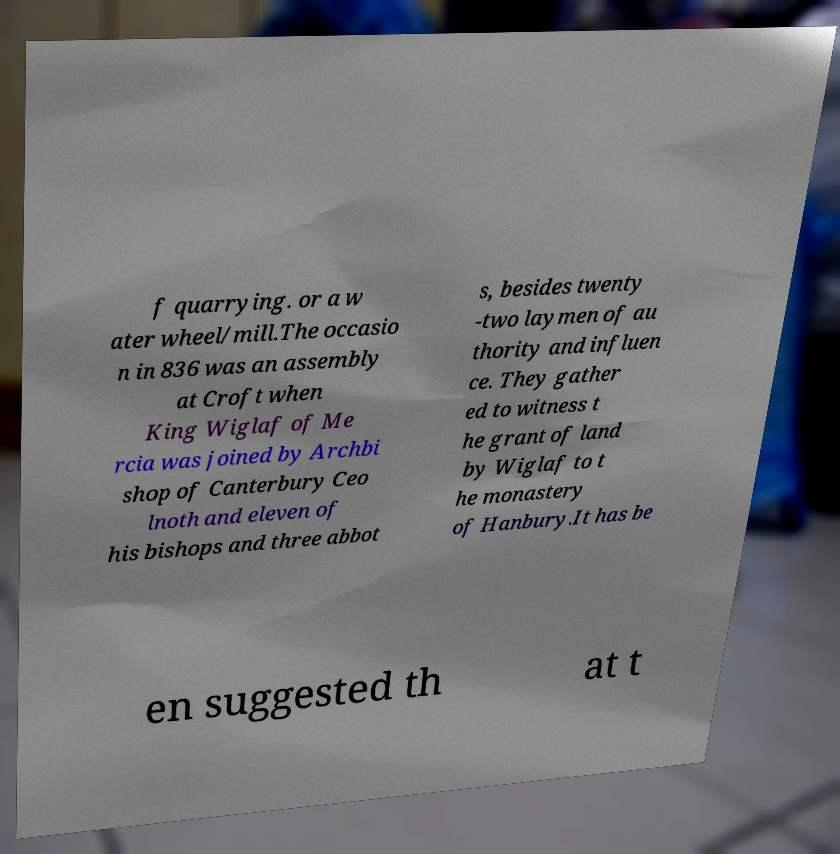Please identify and transcribe the text found in this image. f quarrying. or a w ater wheel/mill.The occasio n in 836 was an assembly at Croft when King Wiglaf of Me rcia was joined by Archbi shop of Canterbury Ceo lnoth and eleven of his bishops and three abbot s, besides twenty -two laymen of au thority and influen ce. They gather ed to witness t he grant of land by Wiglaf to t he monastery of Hanbury.It has be en suggested th at t 